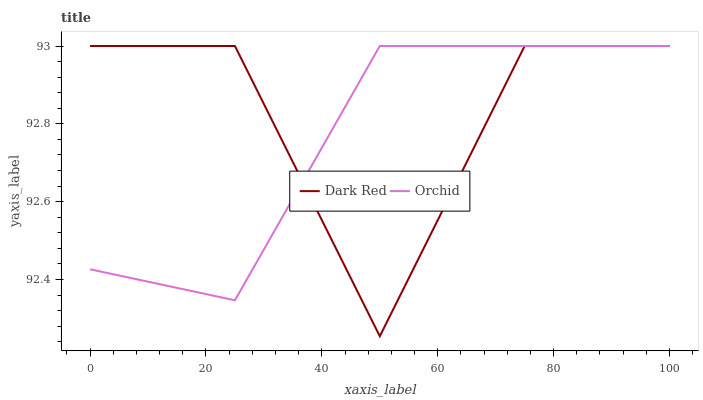Does Orchid have the minimum area under the curve?
Answer yes or no. Yes. Does Dark Red have the maximum area under the curve?
Answer yes or no. Yes. Does Orchid have the maximum area under the curve?
Answer yes or no. No. Is Orchid the smoothest?
Answer yes or no. Yes. Is Dark Red the roughest?
Answer yes or no. Yes. Is Orchid the roughest?
Answer yes or no. No. Does Dark Red have the lowest value?
Answer yes or no. Yes. Does Orchid have the lowest value?
Answer yes or no. No. Does Orchid have the highest value?
Answer yes or no. Yes. Does Dark Red intersect Orchid?
Answer yes or no. Yes. Is Dark Red less than Orchid?
Answer yes or no. No. Is Dark Red greater than Orchid?
Answer yes or no. No. 